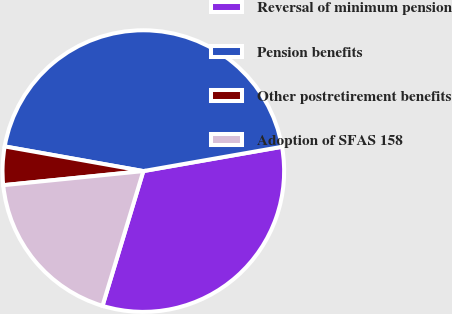<chart> <loc_0><loc_0><loc_500><loc_500><pie_chart><fcel>Reversal of minimum pension<fcel>Pension benefits<fcel>Other postretirement benefits<fcel>Adoption of SFAS 158<nl><fcel>32.44%<fcel>44.44%<fcel>4.4%<fcel>18.72%<nl></chart> 